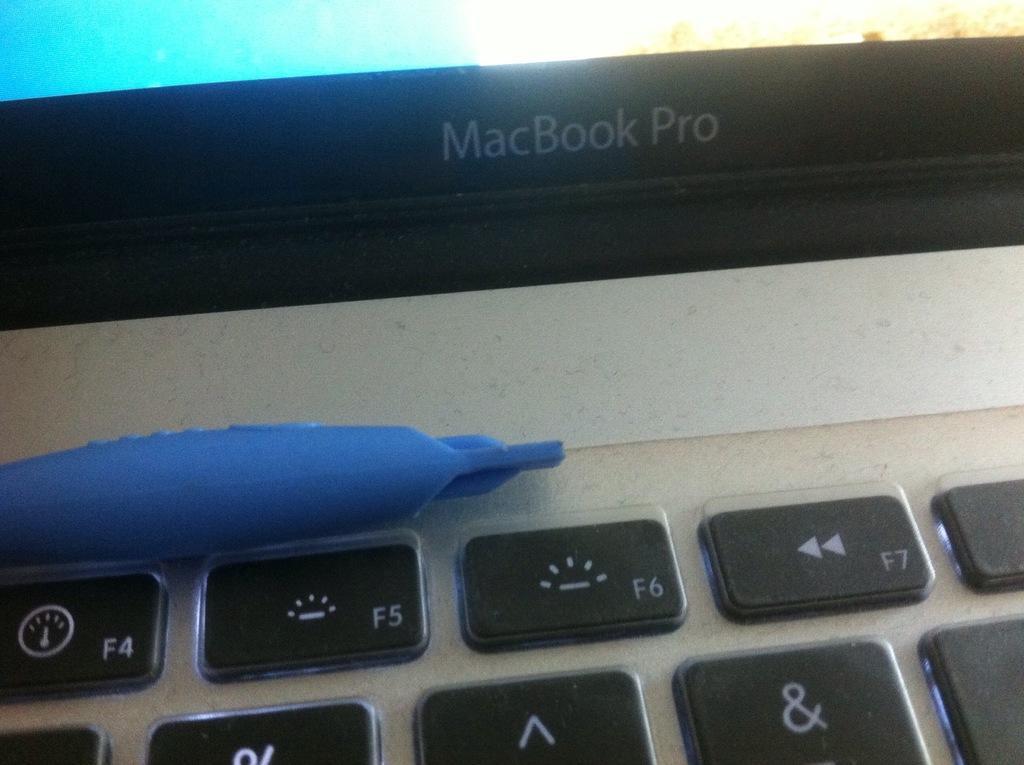How would you summarize this image in a sentence or two? In this image in the foreground there is one laptop, and on the laptop there is some object. 